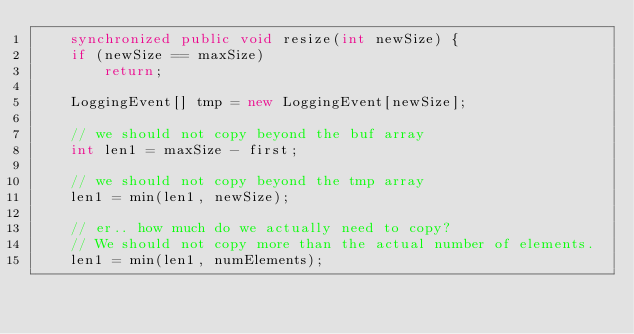Convert code to text. <code><loc_0><loc_0><loc_500><loc_500><_Java_>    synchronized public void resize(int newSize) {
	if (newSize == maxSize)
	    return;

	LoggingEvent[] tmp = new LoggingEvent[newSize];

	// we should not copy beyond the buf array
	int len1 = maxSize - first;

	// we should not copy beyond the tmp array
	len1 = min(len1, newSize);

	// er.. how much do we actually need to copy?
	// We should not copy more than the actual number of elements.
	len1 = min(len1, numElements);
</code> 